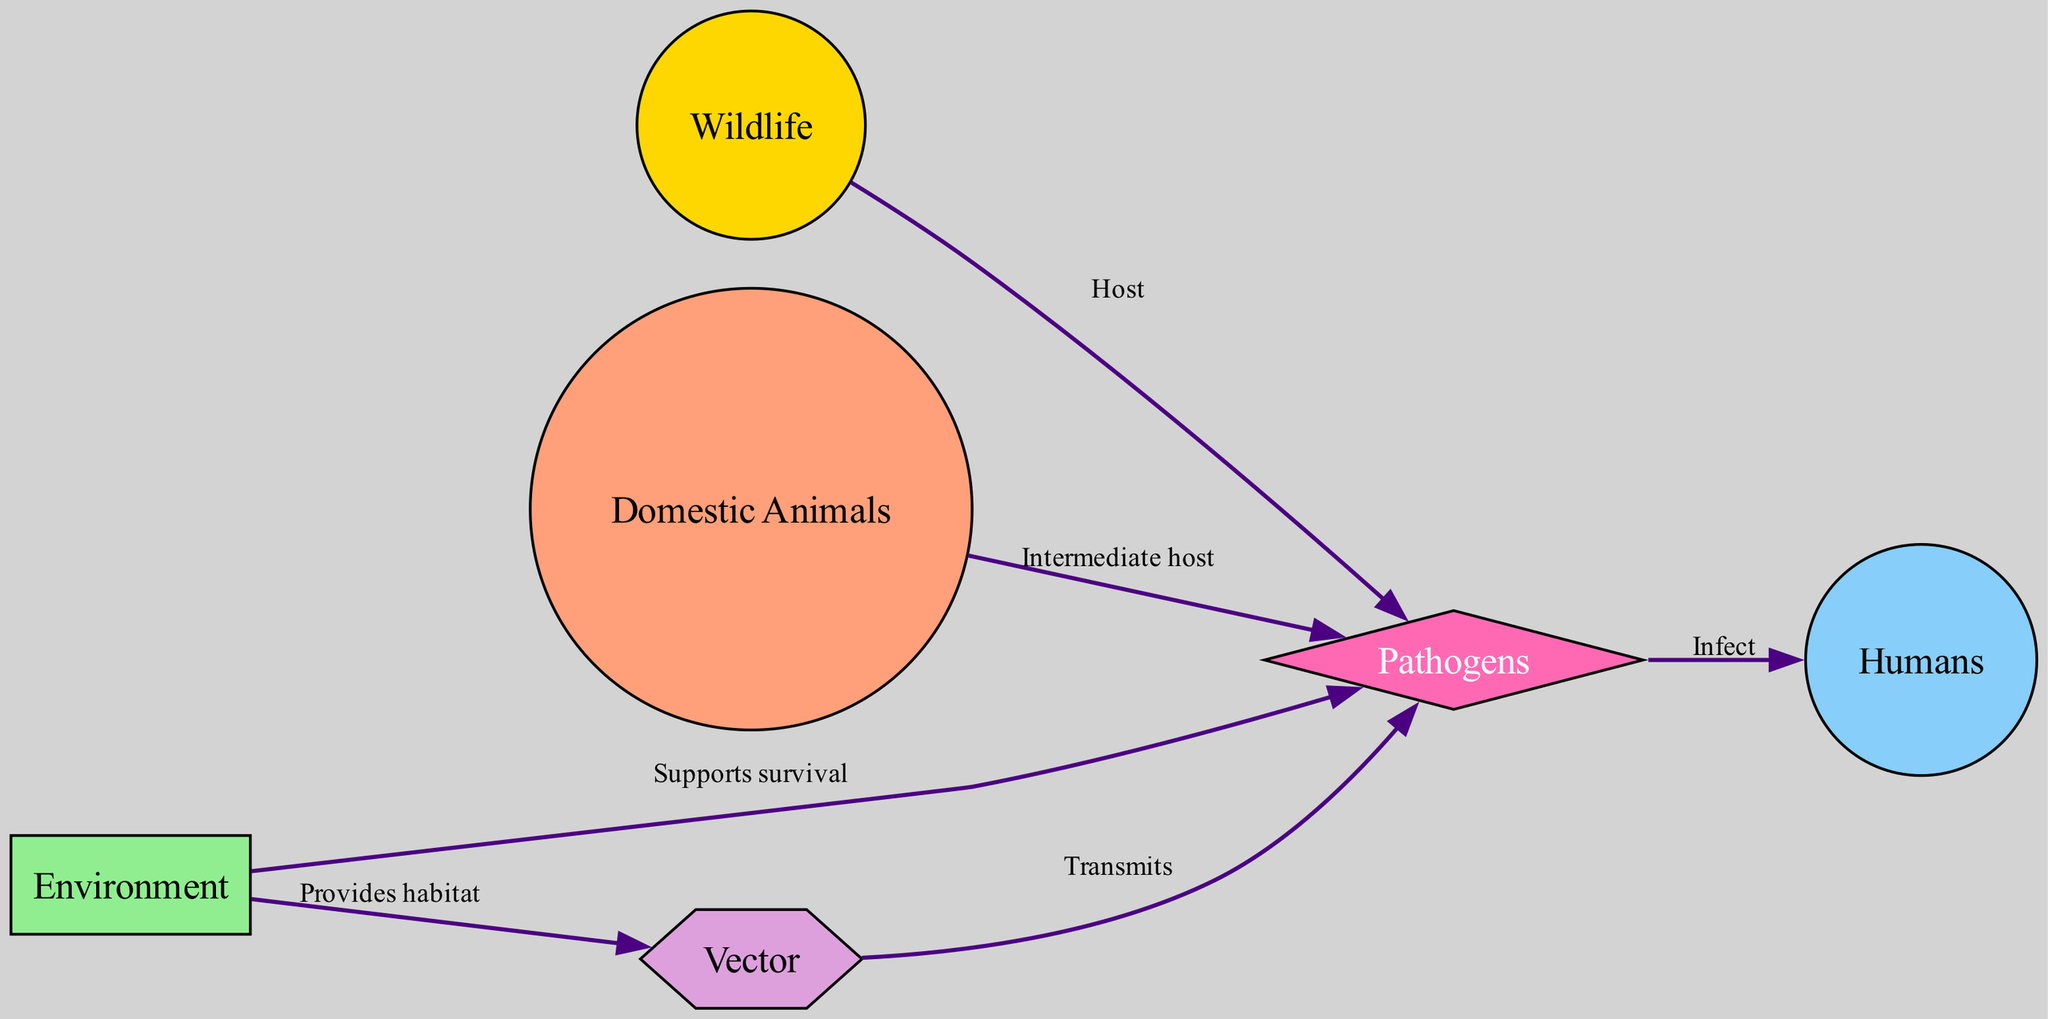What are the primary nodes in the diagram? The diagram has six primary nodes: Wildlife, Domestic Animals, Humans, Environment, Pathogens, and Vector. These nodes represent the key components involved in zoonotic disease transmission.
Answer: Wildlife, Domestic Animals, Humans, Environment, Pathogens, Vector How many edges connect the node "Pathogens"? The "Pathogens" node is connected by four edges, indicating relationships with Wildlife, Domestic Animals, Humans, and Environment. Each edge illustrates a different aspect of how pathogens interact with other components.
Answer: 4 What relationship does the "Vector" have with "Pathogens"? The relationship is that the "Vector" transmits "Pathogens", as indicated by the labeling on the edge connecting these nodes. This shows the vector's role in facilitating disease spread.
Answer: Transmits Which node provides habitat for the "Vector"? The "Environment" node provides habitat for the "Vector," as indicated by the labeled edge connecting them. This shows how environmental factors support the living conditions needed for vectors.
Answer: Provides habitat What is the function of "Domestic Animals" in relation to "Pathogens"? "Domestic Animals" function as an intermediate host for "Pathogens," facilitating the transmission and spread of diseases to humans. This relationship emphasizes the role of domesticated animals in zoonotic disease dynamics.
Answer: Intermediate host Explain the flow of transmission from "Wildlife" to "Humans". The flow begins with "Wildlife" acting as a host for "Pathogens". From there, "Pathogens" can infect "Humans" directly. This sequence highlights the potential risk humans face from zoonotic diseases originating in wildlife.
Answer: Wildlife to Pathogens to Humans What does the "Environment" do for "Pathogens"? The "Environment" supports the survival of "Pathogens," providing the necessary conditions for them to thrive and potentially infect hosts. This relationship outlines the importance of environmental factors in disease ecology.
Answer: Supports survival How is "Domestic Animals" related to "Humans"? The relationship stems from the transmission of "Pathogens" from "Domestic Animals" to "Humans," indicating a direct link where diseases can spread from animals to people. This highlights zoonotic transmission pathways involving domestic animals.
Answer: Infect What shapes represent the nodes in the diagram? The nodes are represented by various shapes: Wildlife and Domestic Animals are circles, Humans are a circle, Environment is a rectangle, Pathogens are a diamond, and Vector is a hexagon. This variety of shapes visually differentiates the types of entities involved.
Answer: Circle, Circle, Circle, Rectangle, Diamond, Hexagon 